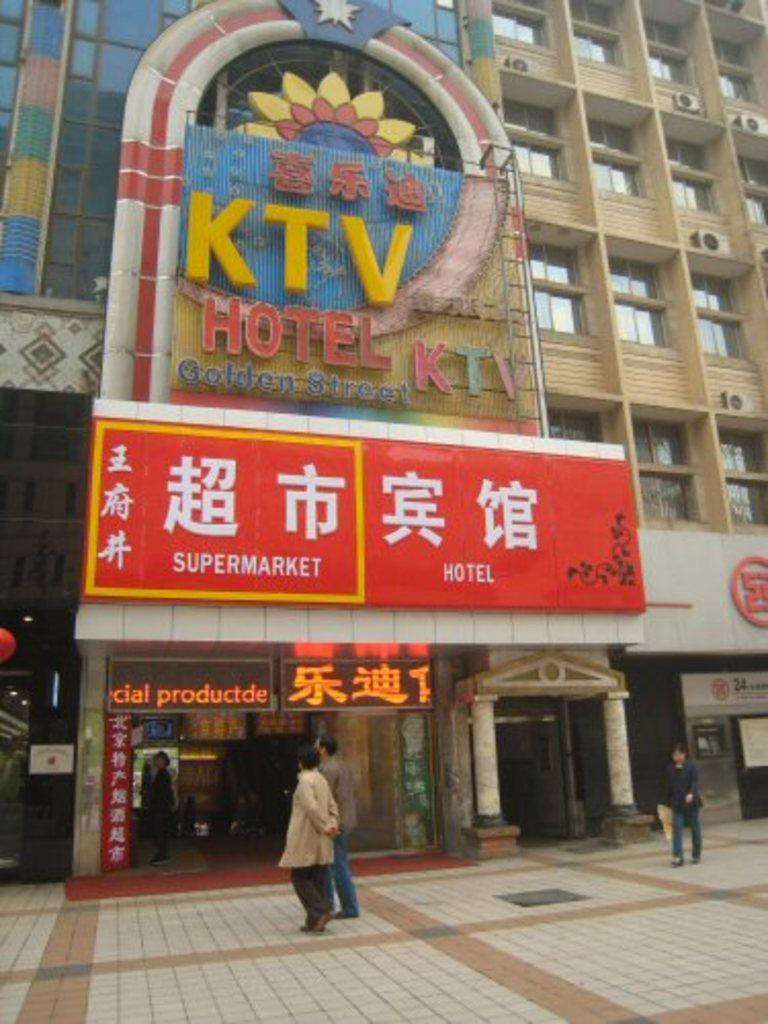What are the people at the bottom of the image doing? The people at the bottom of the image are standing and walking. What is located behind the people? There is a building behind the people. What can be seen on the building? There are banners on the building. Can you see a kitty playing on the stage in the image? There is no stage or kitty present in the image. Is there a lake visible in the background of the image? There is no lake visible in the image; only a building with banners is present. 